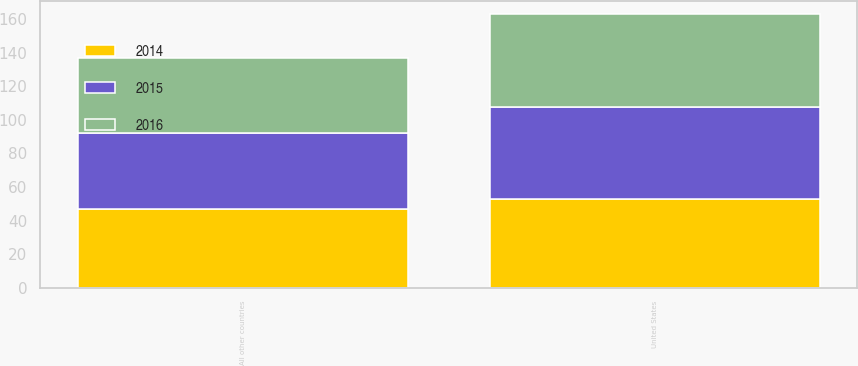Convert chart to OTSL. <chart><loc_0><loc_0><loc_500><loc_500><stacked_bar_chart><ecel><fcel>United States<fcel>All other countries<nl><fcel>2016<fcel>55<fcel>45<nl><fcel>2015<fcel>55<fcel>45<nl><fcel>2014<fcel>53<fcel>47<nl></chart> 